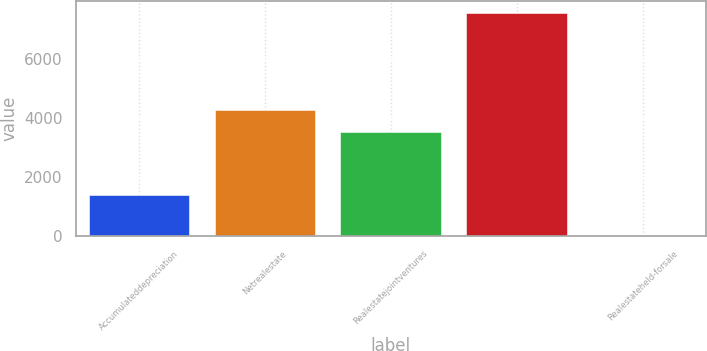Convert chart to OTSL. <chart><loc_0><loc_0><loc_500><loc_500><bar_chart><fcel>Accumulateddepreciation<fcel>Netrealestate<fcel>Realestatejointventures<fcel>Unnamed: 3<fcel>Realestateheld-forsale<nl><fcel>1378<fcel>4280.4<fcel>3522<fcel>7585<fcel>1<nl></chart> 